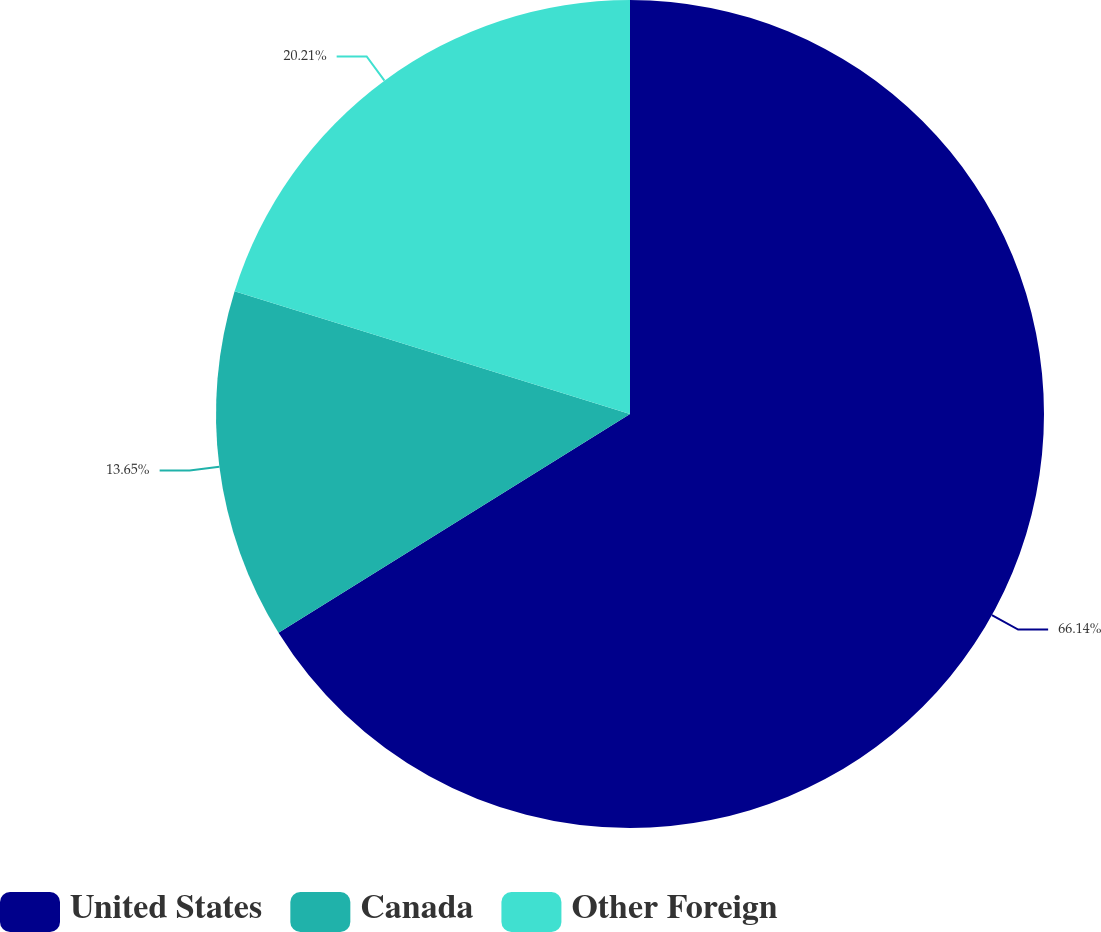Convert chart to OTSL. <chart><loc_0><loc_0><loc_500><loc_500><pie_chart><fcel>United States<fcel>Canada<fcel>Other Foreign<nl><fcel>66.14%<fcel>13.65%<fcel>20.21%<nl></chart> 